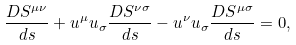Convert formula to latex. <formula><loc_0><loc_0><loc_500><loc_500>\frac { D S ^ { \mu \nu } } { d s } + u ^ { \mu } u _ { \sigma } \frac { D S ^ { \nu \sigma } } { d s } - u ^ { \nu } u _ { \sigma } \frac { D S ^ { \mu \sigma } } { d s } = 0 ,</formula> 